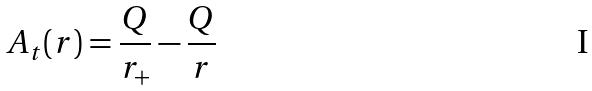Convert formula to latex. <formula><loc_0><loc_0><loc_500><loc_500>A _ { t } ( r ) = \frac { Q } { r _ { + } } - \frac { Q } { r }</formula> 